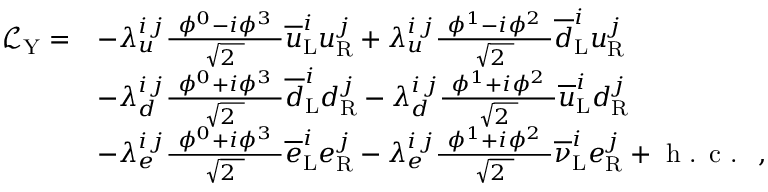<formula> <loc_0><loc_0><loc_500><loc_500>{ \begin{array} { r l } { { \mathcal { L } } _ { Y } = } & { - \lambda _ { u } ^ { i \, j } { \frac { \ \phi ^ { 0 } - i \phi ^ { 3 } \ } { \sqrt { 2 \ } } } { \overline { u } } _ { L } ^ { i } u _ { R } ^ { j } + \lambda _ { u } ^ { i \, j } { \frac { \ \phi ^ { 1 } - i \phi ^ { 2 } \ } { \sqrt { 2 \ } } } { \overline { d } } _ { L } ^ { i } u _ { R } ^ { j } } \\ & { - \lambda _ { d } ^ { i \, j } { \frac { \ \phi ^ { 0 } + i \phi ^ { 3 } \ } { \sqrt { 2 \ } } } { \overline { d } } _ { L } ^ { i } d _ { R } ^ { j } - \lambda _ { d } ^ { i \, j } { \frac { \ \phi ^ { 1 } + i \phi ^ { 2 } \ } { \sqrt { 2 \ } } } { \overline { u } } _ { L } ^ { i } d _ { R } ^ { j } } \\ & { - \lambda _ { e } ^ { i \, j } { \frac { \ \phi ^ { 0 } + i \phi ^ { 3 } \ } { \sqrt { 2 \ } } } { \overline { e } } _ { L } ^ { i } e _ { R } ^ { j } - \lambda _ { e } ^ { i \, j } { \frac { \ \phi ^ { 1 } + i \phi ^ { 2 } \ } { \sqrt { 2 \ } } } { \overline { \nu } } _ { L } ^ { i } e _ { R } ^ { j } + { h . c . } \ , } \end{array} }</formula> 